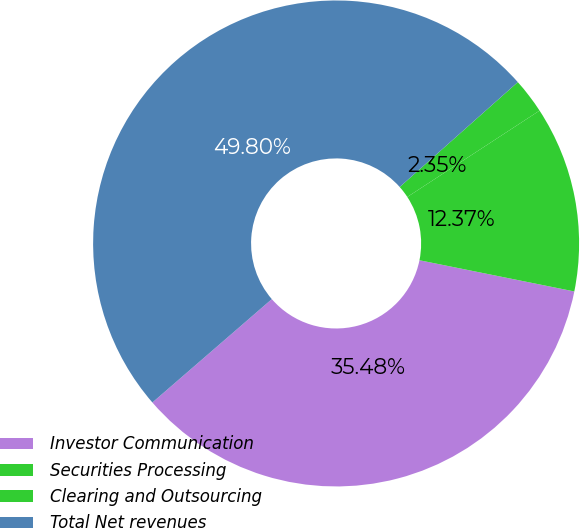Convert chart to OTSL. <chart><loc_0><loc_0><loc_500><loc_500><pie_chart><fcel>Investor Communication<fcel>Securities Processing<fcel>Clearing and Outsourcing<fcel>Total Net revenues<nl><fcel>35.48%<fcel>12.37%<fcel>2.35%<fcel>49.8%<nl></chart> 